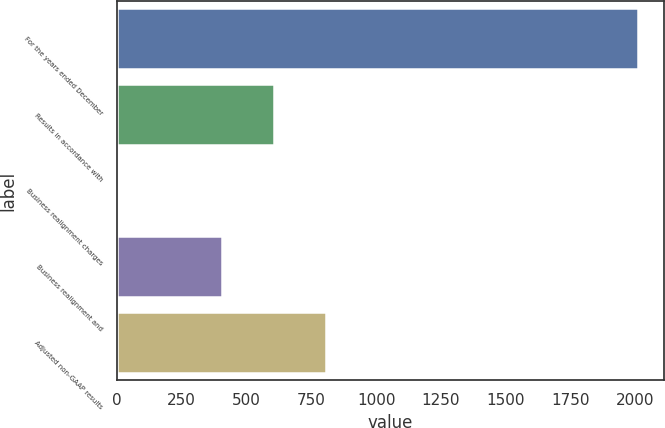Convert chart. <chart><loc_0><loc_0><loc_500><loc_500><bar_chart><fcel>For the years ended December<fcel>Results in accordance with<fcel>Business realignment charges<fcel>Business realignment and<fcel>Adjusted non-GAAP results<nl><fcel>2009<fcel>605.36<fcel>3.8<fcel>404.84<fcel>805.88<nl></chart> 